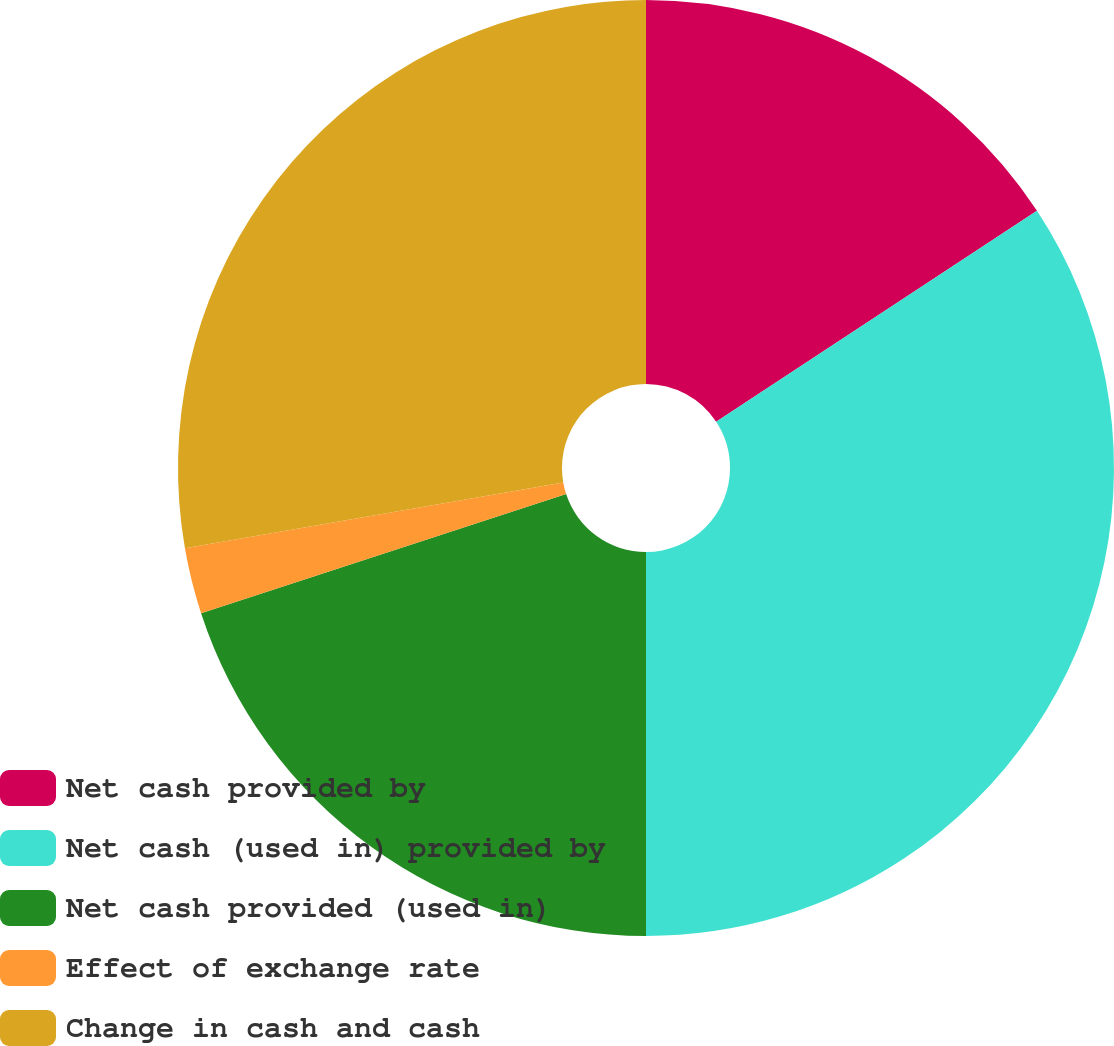<chart> <loc_0><loc_0><loc_500><loc_500><pie_chart><fcel>Net cash provided by<fcel>Net cash (used in) provided by<fcel>Net cash provided (used in)<fcel>Effect of exchange rate<fcel>Change in cash and cash<nl><fcel>15.74%<fcel>34.26%<fcel>19.98%<fcel>2.28%<fcel>27.74%<nl></chart> 